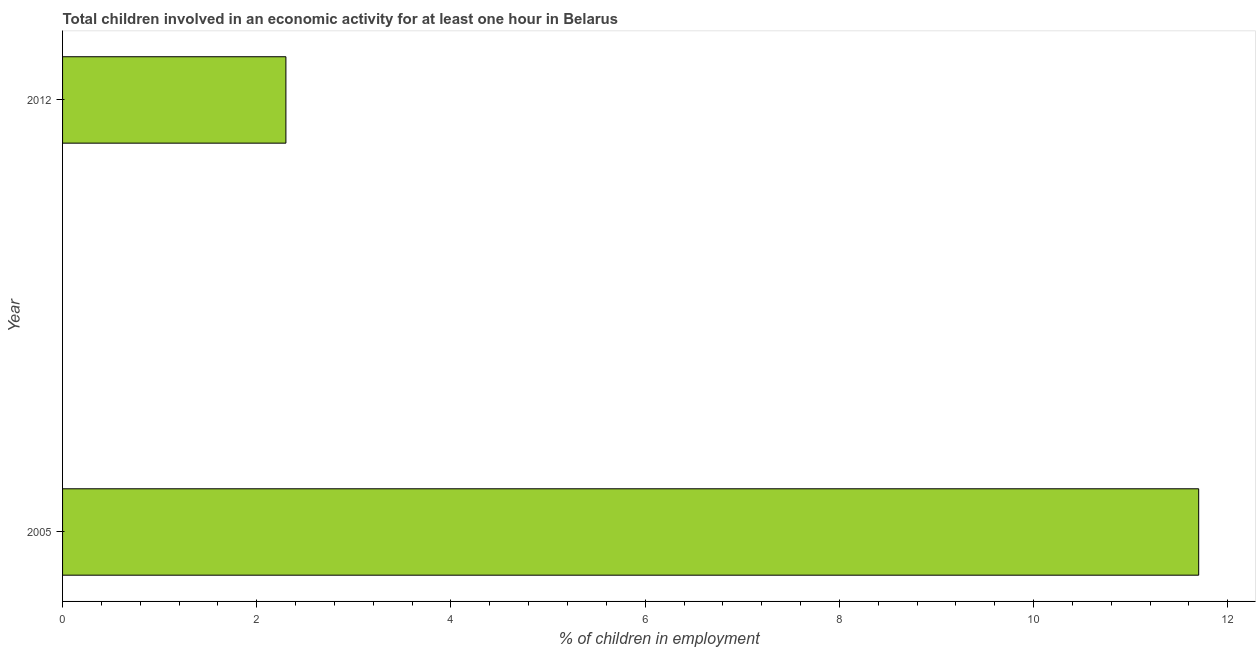What is the title of the graph?
Provide a short and direct response. Total children involved in an economic activity for at least one hour in Belarus. What is the label or title of the X-axis?
Offer a very short reply. % of children in employment. What is the label or title of the Y-axis?
Ensure brevity in your answer.  Year. Across all years, what is the minimum percentage of children in employment?
Make the answer very short. 2.3. In which year was the percentage of children in employment maximum?
Give a very brief answer. 2005. What is the difference between the percentage of children in employment in 2005 and 2012?
Provide a succinct answer. 9.4. What is the average percentage of children in employment per year?
Your answer should be very brief. 7. What is the median percentage of children in employment?
Your answer should be very brief. 7. What is the ratio of the percentage of children in employment in 2005 to that in 2012?
Offer a terse response. 5.09. How many years are there in the graph?
Your answer should be very brief. 2. Are the values on the major ticks of X-axis written in scientific E-notation?
Provide a succinct answer. No. What is the % of children in employment of 2005?
Ensure brevity in your answer.  11.7. What is the ratio of the % of children in employment in 2005 to that in 2012?
Offer a terse response. 5.09. 